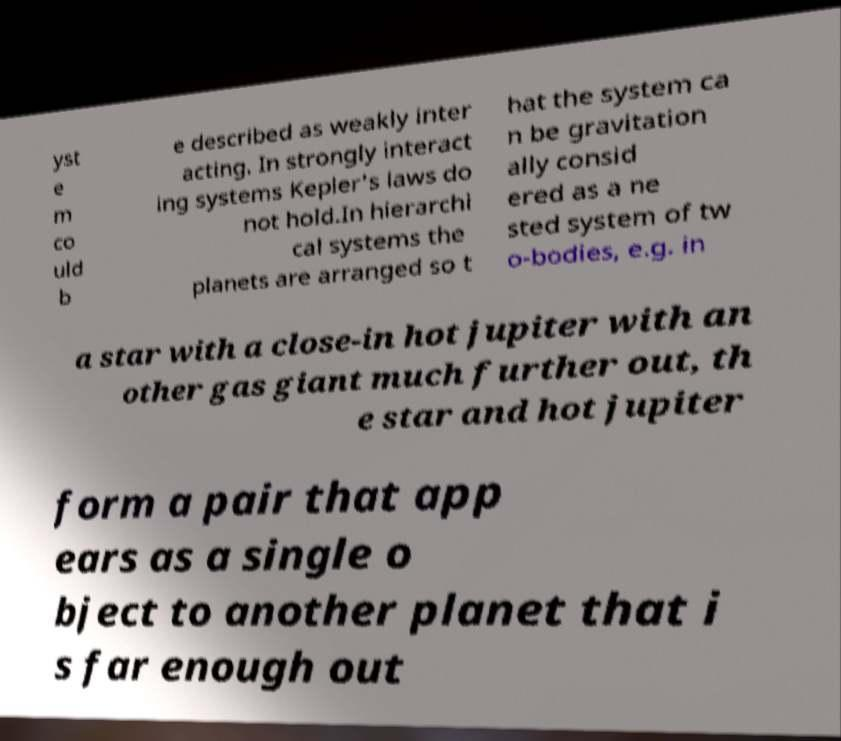Could you extract and type out the text from this image? yst e m co uld b e described as weakly inter acting. In strongly interact ing systems Kepler's laws do not hold.In hierarchi cal systems the planets are arranged so t hat the system ca n be gravitation ally consid ered as a ne sted system of tw o-bodies, e.g. in a star with a close-in hot jupiter with an other gas giant much further out, th e star and hot jupiter form a pair that app ears as a single o bject to another planet that i s far enough out 